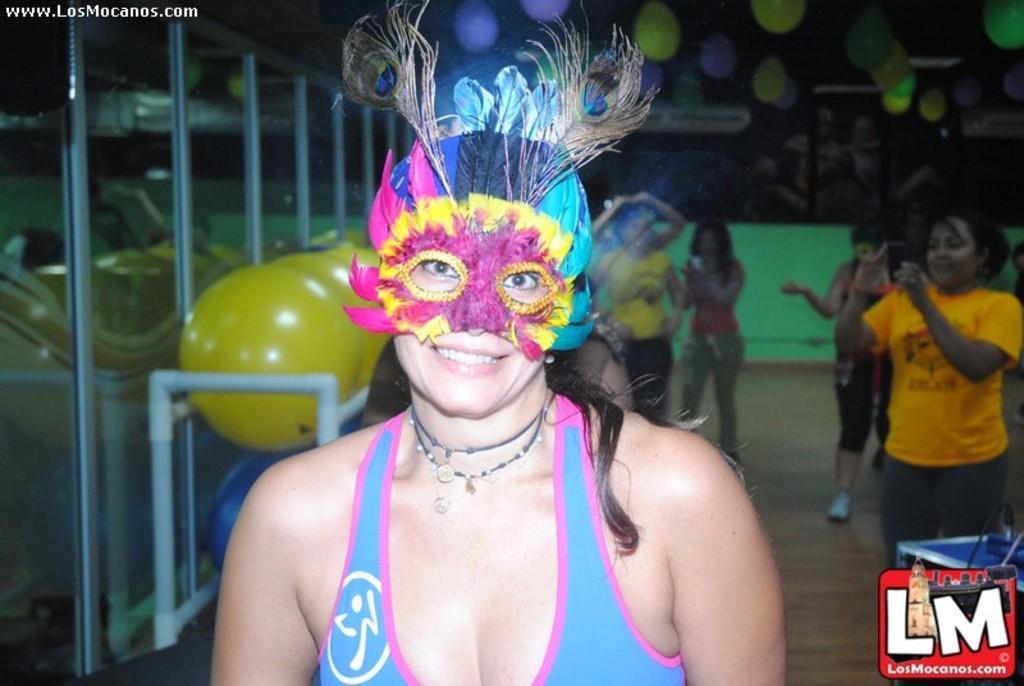Please provide a concise description of this image. In this image we can see a woman wearing eye mask on her face is smiling. In the background, we can see a few more people standing on the floor, balloons and the glass door. Here we can see the watermark. 